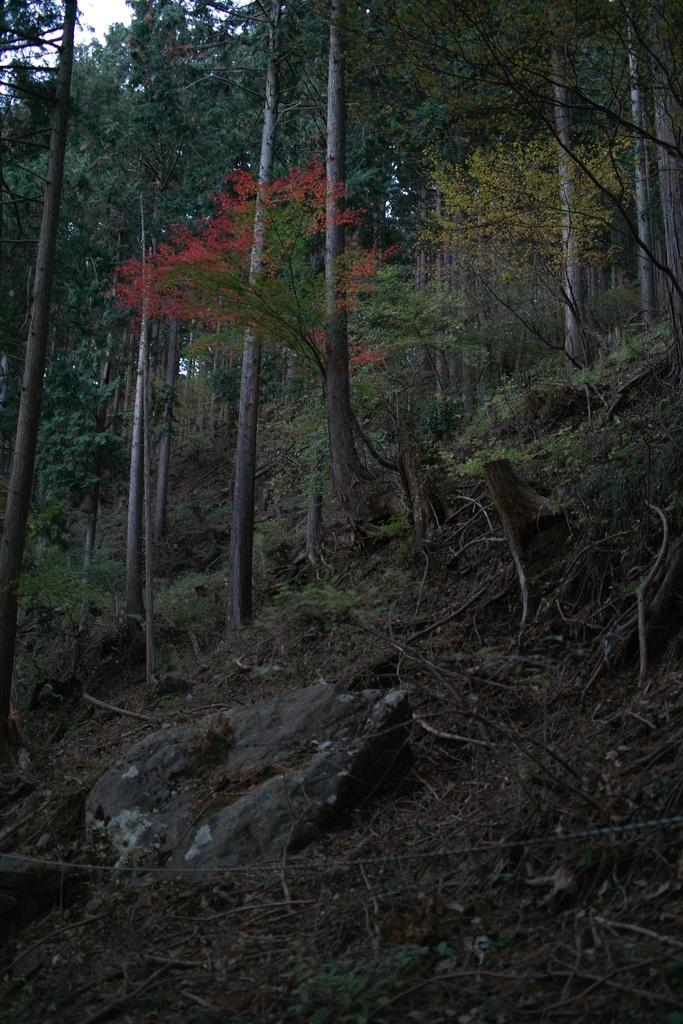What type of vegetation can be seen in the image? There are trees in the image. What object is located on the ground in the image? There is a stone on the ground in the image. What part of the natural environment is visible in the image? The sky is visible in the background of the image. Where is the badge located in the image? There is no badge present in the image. What type of range can be seen in the image? There is no range present in the image. 